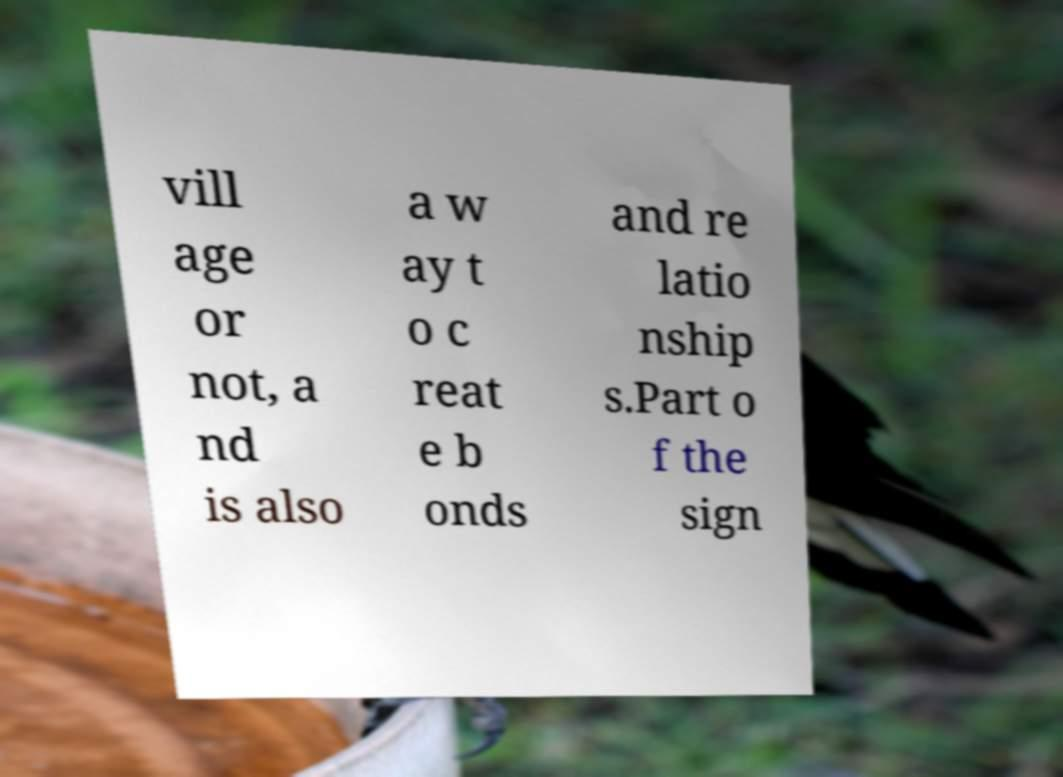Please identify and transcribe the text found in this image. vill age or not, a nd is also a w ay t o c reat e b onds and re latio nship s.Part o f the sign 